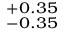Convert formula to latex. <formula><loc_0><loc_0><loc_500><loc_500>^ { + 0 . 3 5 } _ { - 0 . 3 5 }</formula> 